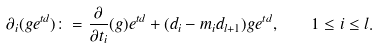<formula> <loc_0><loc_0><loc_500><loc_500>\partial _ { i } ( g e ^ { t d } ) \colon = \frac { \partial } { \partial t _ { i } } ( g ) e ^ { t d } + ( d _ { i } - m _ { i } d _ { l + 1 } ) g e ^ { t d } , \quad 1 \leq i \leq l .</formula> 